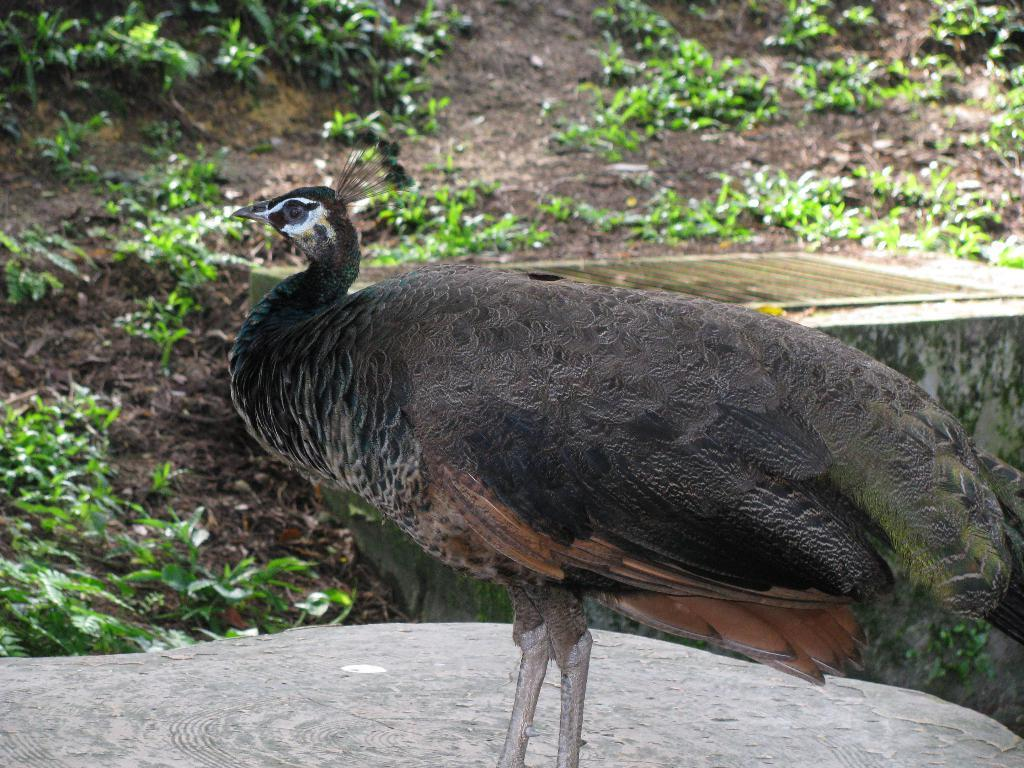What type of animal is in the image? There is a bird in the image. Can you describe the bird's coloring? The bird has black and brown colors. What can be seen in the background of the image? There are plants in the background of the image. What color are the plants? The plants are green in color. What is the price of the mice in the image? There are no mice present in the image, so it is not possible to determine the price. 